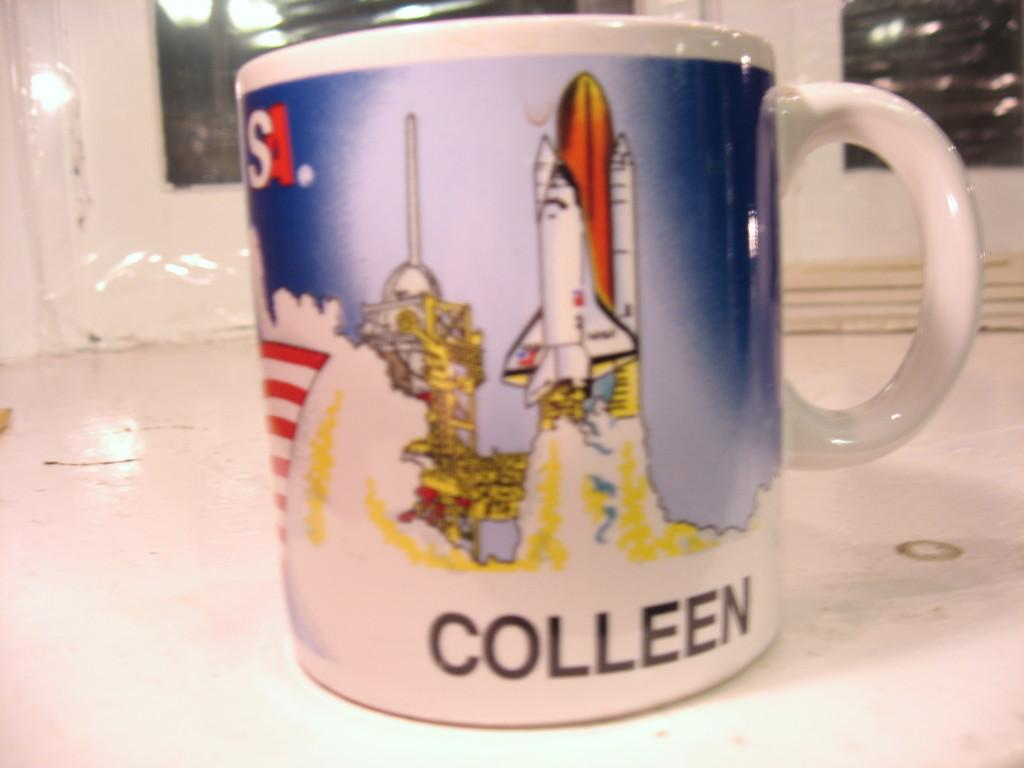<image>
Render a clear and concise summary of the photo. A space shuttle launch mug is personalized for Colleen. 